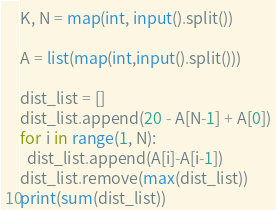<code> <loc_0><loc_0><loc_500><loc_500><_Python_>K, N = map(int, input().split())

A = list(map(int,input().split()))

dist_list = []
dist_list.append(20 - A[N-1] + A[0])
for i in range(1, N):
  dist_list.append(A[i]-A[i-1])
dist_list.remove(max(dist_list))
print(sum(dist_list))
</code> 